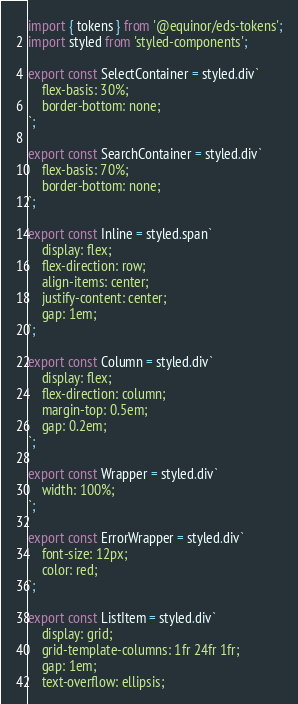<code> <loc_0><loc_0><loc_500><loc_500><_TypeScript_>import { tokens } from '@equinor/eds-tokens';
import styled from 'styled-components';

export const SelectContainer = styled.div`
    flex-basis: 30%;
    border-bottom: none;
`;

export const SearchContainer = styled.div`
    flex-basis: 70%;
    border-bottom: none;
`;

export const Inline = styled.span`
    display: flex;
    flex-direction: row;
    align-items: center;
    justify-content: center;
    gap: 1em;
`;

export const Column = styled.div`
    display: flex;
    flex-direction: column;
    margin-top: 0.5em;
    gap: 0.2em;
`;

export const Wrapper = styled.div`
    width: 100%;
`;

export const ErrorWrapper = styled.div`
    font-size: 12px;
    color: red;
`;

export const ListItem = styled.div`
    display: grid;
    grid-template-columns: 1fr 24fr 1fr;
    gap: 1em;
    text-overflow: ellipsis;</code> 